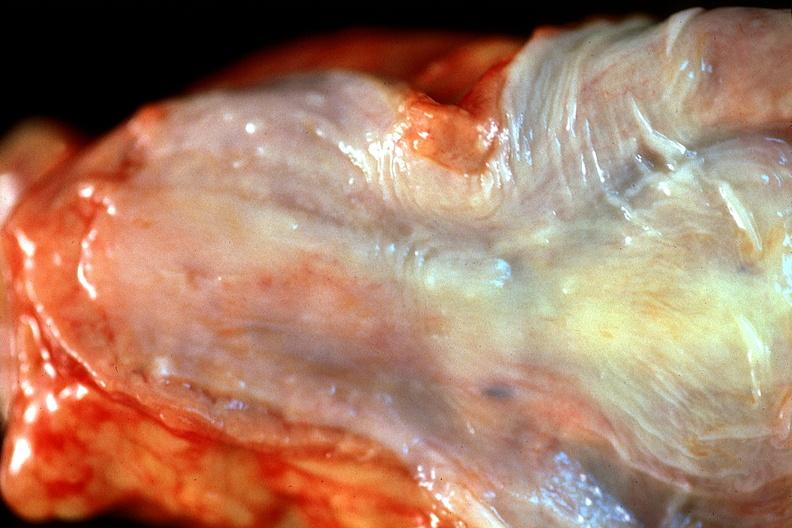s gastrointestinal present?
Answer the question using a single word or phrase. Yes 